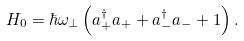Convert formula to latex. <formula><loc_0><loc_0><loc_500><loc_500>H _ { 0 } = \hbar { \omega } _ { \perp } \left ( a _ { + } ^ { \dagger } a _ { + } + a _ { - } ^ { \dagger } a _ { - } + 1 \right ) .</formula> 